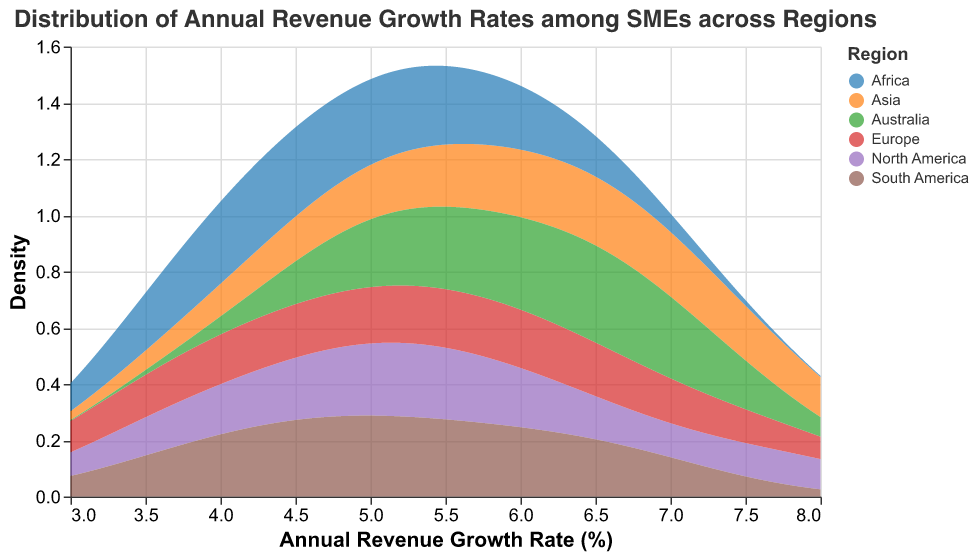What is the title of the figure? The title is typically written at the top of the figure, providing a summary of what the plot represents. Here, it is easy to spot and read.
Answer: Distribution of Annual Revenue Growth Rates among SMEs across Regions On which axis is the Annual Revenue Growth Rate displayed? In the figure, axes usually label what data they represent. The bottom axis (horizontal) shows the Annual Revenue Growth Rate.
Answer: x-axis Which region appears to have the widest distribution of annual revenue growth rates? By inspecting the density plots for each region, the width of the distribution indicates how spread out the revenue growth rates are.
Answer: Asia Which region has the highest peak density observed in the distribution? The peak density for each region can be identified by finding the highest point on their respective density plot.
Answer: Africa Which regions show a revenue growth rate centered around 5%? Revenue growth rates centered around a certain value would have their peak density around that value on the x-axis. Regions with peaks near 5% are identified.
Answer: North America, Asia, and Europa How does the peak density of Europe compare to that of Australia? To compare peak densities, observe the highest points for both regions' distributions and compare their heights.
Answer: Europe has a lower peak density compared to Australia Which region has the least variability in its revenue growth rates? The least variability is indicated by the narrowest distribution, with the density tightly clustered around the mean value.
Answer: North America What is the approximate range of the annual revenue growth rate for South America? The range can be approximated by observing the horizontal spread of the density plot from the starting to the ending point.
Answer: Approximately 3.5% to 7% Do any regions have similar distributions of growth rates? Regions with similar shapes and peaks in their density plots indicate similar distributions.
Answer: Yes, Africa and Australia have similar distributions Which region has the highest maximum annual revenue growth rate? The region with the farthest right-side peak on the x-axis indicates the highest maximum revenue growth rate.
Answer: Asia 